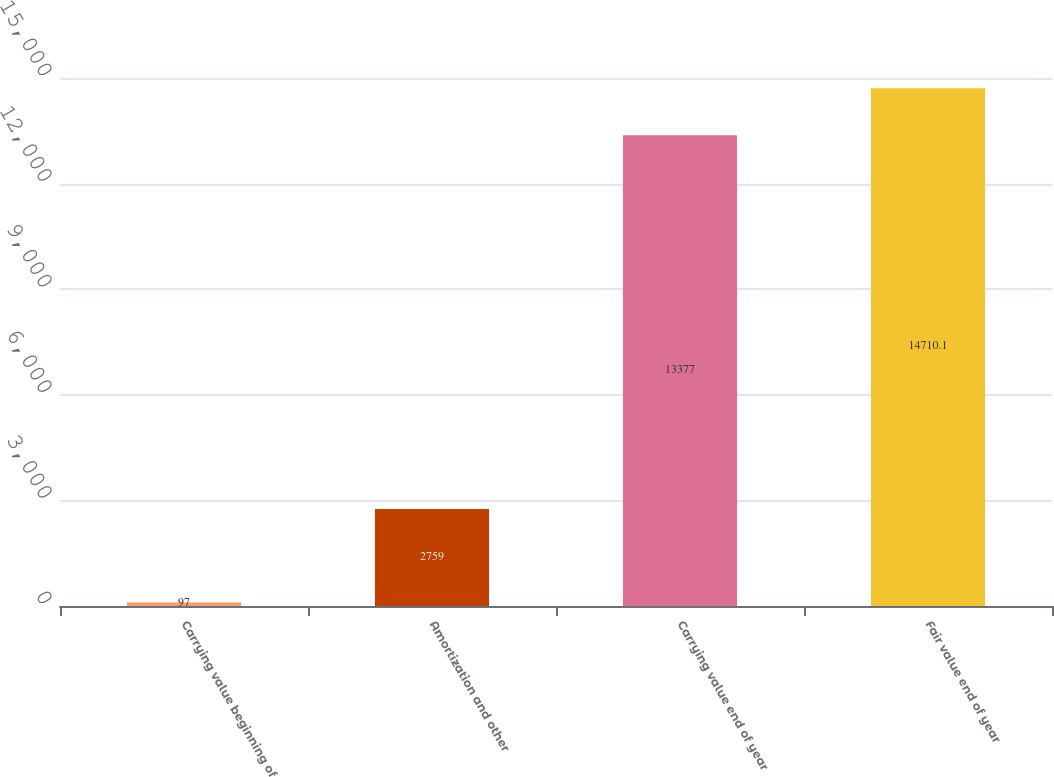<chart> <loc_0><loc_0><loc_500><loc_500><bar_chart><fcel>Carrying value beginning of<fcel>Amortization and other<fcel>Carrying value end of year<fcel>Fair value end of year<nl><fcel>97<fcel>2759<fcel>13377<fcel>14710.1<nl></chart> 